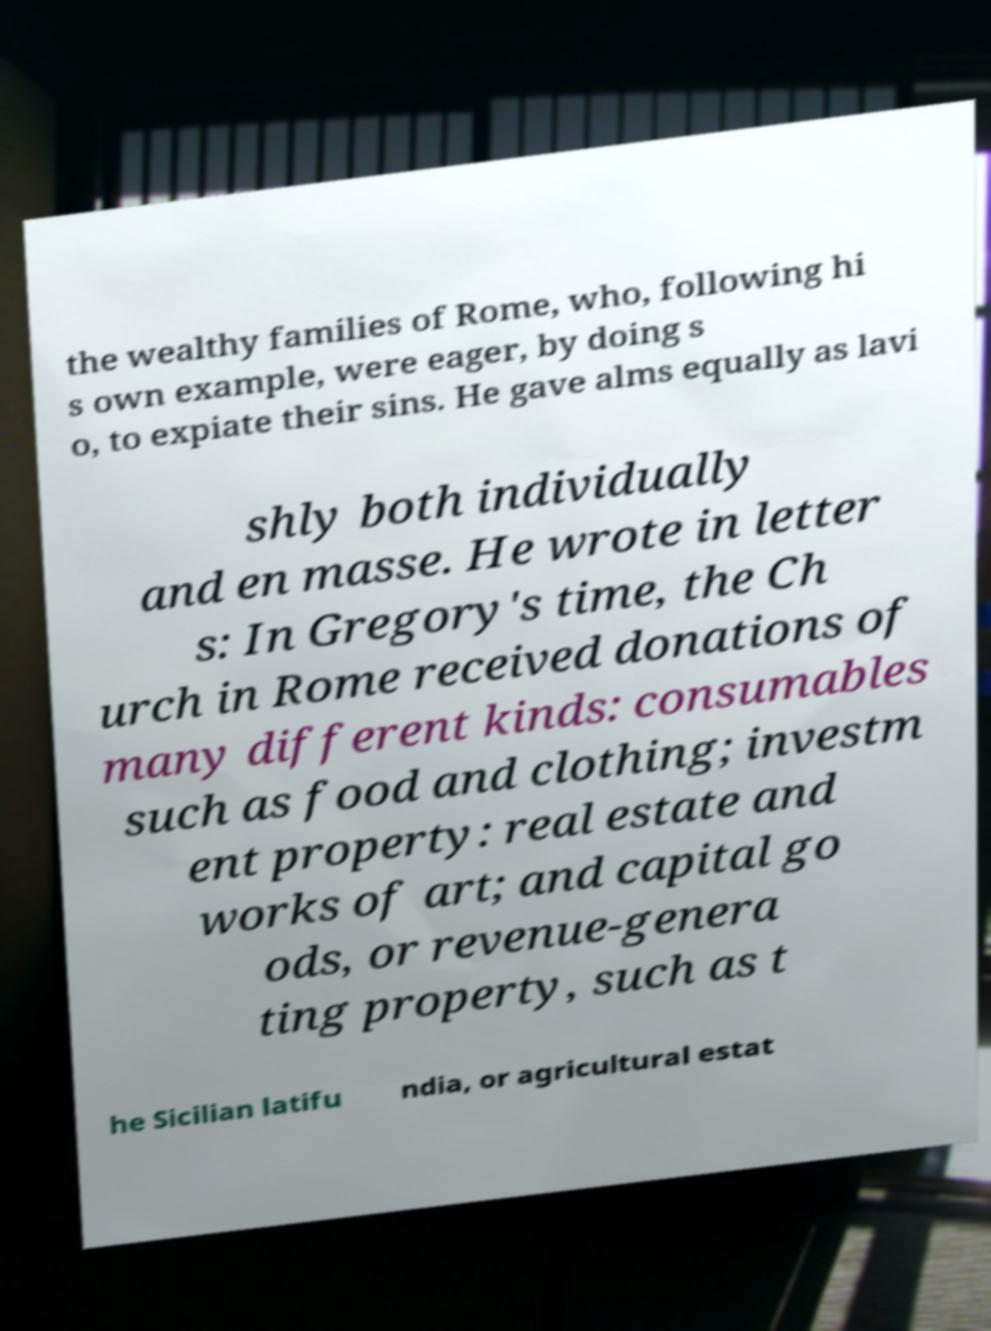For documentation purposes, I need the text within this image transcribed. Could you provide that? the wealthy families of Rome, who, following hi s own example, were eager, by doing s o, to expiate their sins. He gave alms equally as lavi shly both individually and en masse. He wrote in letter s: In Gregory's time, the Ch urch in Rome received donations of many different kinds: consumables such as food and clothing; investm ent property: real estate and works of art; and capital go ods, or revenue-genera ting property, such as t he Sicilian latifu ndia, or agricultural estat 